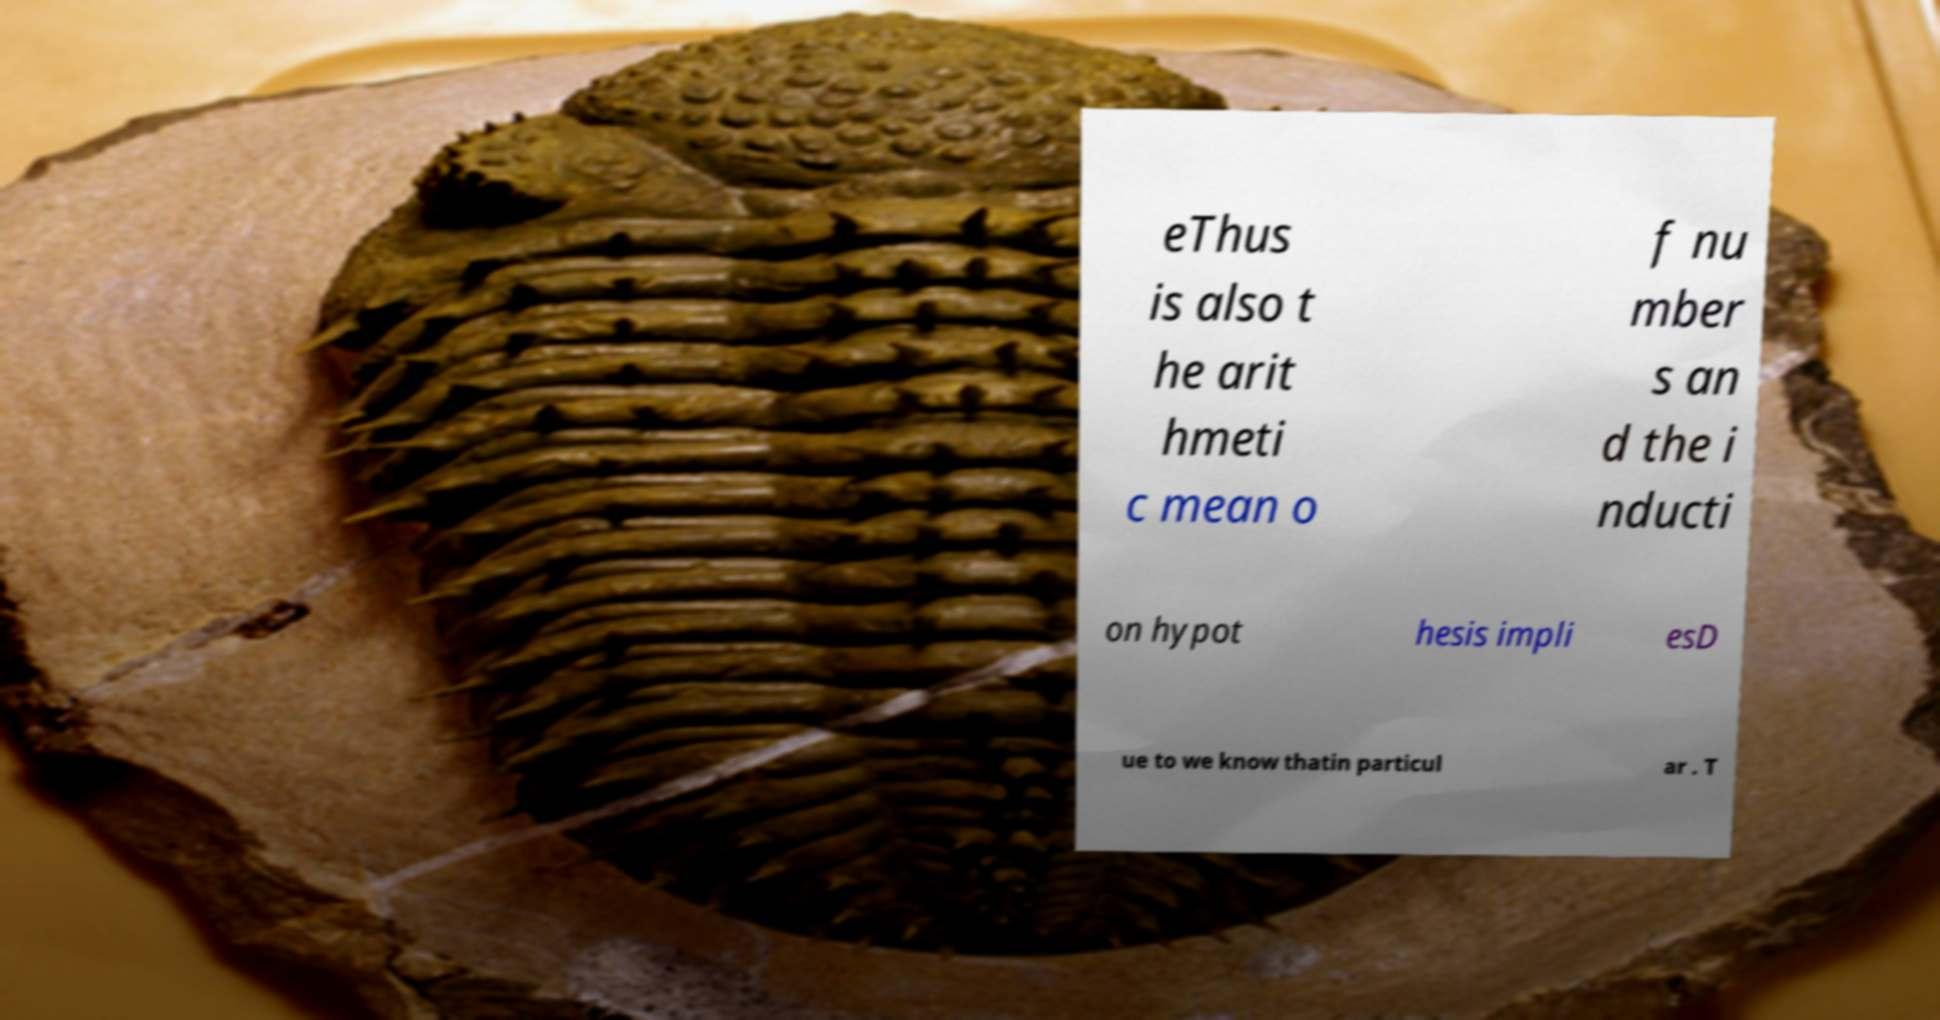I need the written content from this picture converted into text. Can you do that? eThus is also t he arit hmeti c mean o f nu mber s an d the i nducti on hypot hesis impli esD ue to we know thatin particul ar . T 